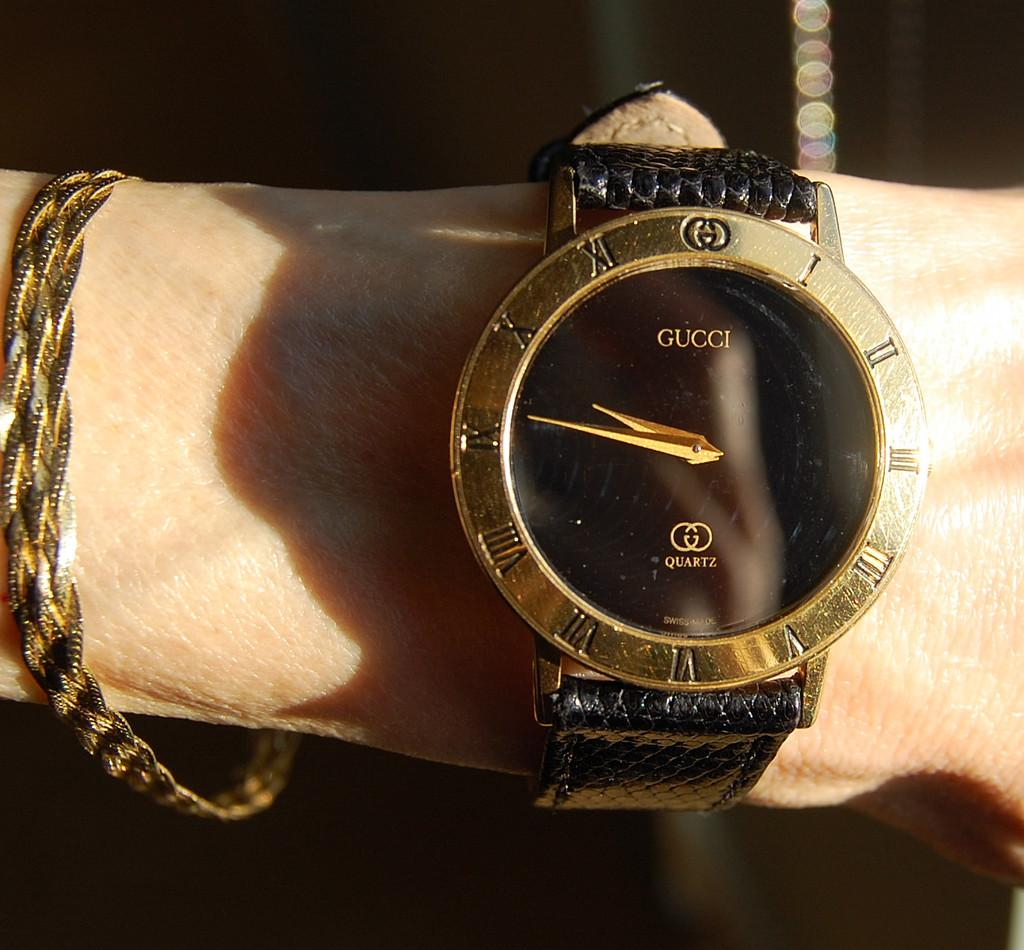<image>
Render a clear and concise summary of the photo. Person wearing a black and gold watch which says Gucci on it. 